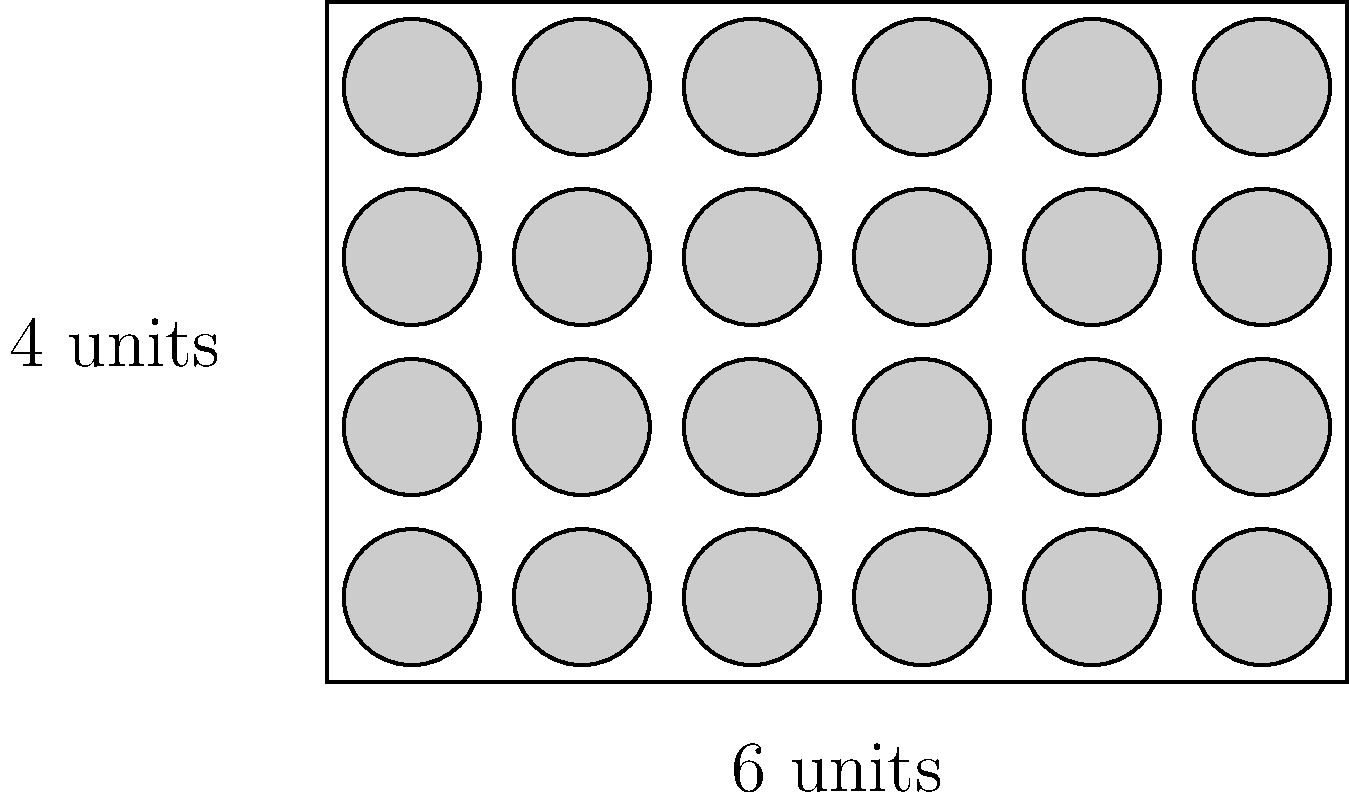During a raid on a suspected moonshine operation, you've discovered a crate filled with bottles. The crate measures 6 units in length and 4 units in width. Each bottle has a diameter of 1 unit. What is the maximum number of bottles that can be arranged in a single layer within this crate to optimize storage efficiency? To solve this problem, we need to follow these steps:

1) First, we need to understand the arrangement. The most efficient way to pack circles (bottles) is in a grid pattern.

2) Given the dimensions of the crate:
   Length = 6 units
   Width = 4 units

3) Since each bottle has a diameter of 1 unit, we can fit:
   - 6 bottles along the length (6 ÷ 1 = 6)
   - 4 bottles along the width (4 ÷ 1 = 4)

4) To calculate the total number of bottles, we multiply:
   $$ \text{Total bottles} = 6 \times 4 = 24 $$

5) This arrangement leaves no wasted space larger than a bottle, ensuring maximum efficiency.

Therefore, the maximum number of bottles that can be arranged in a single layer within this crate is 24.
Answer: 24 bottles 